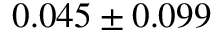<formula> <loc_0><loc_0><loc_500><loc_500>0 . 0 4 5 \pm 0 . 0 9 9</formula> 